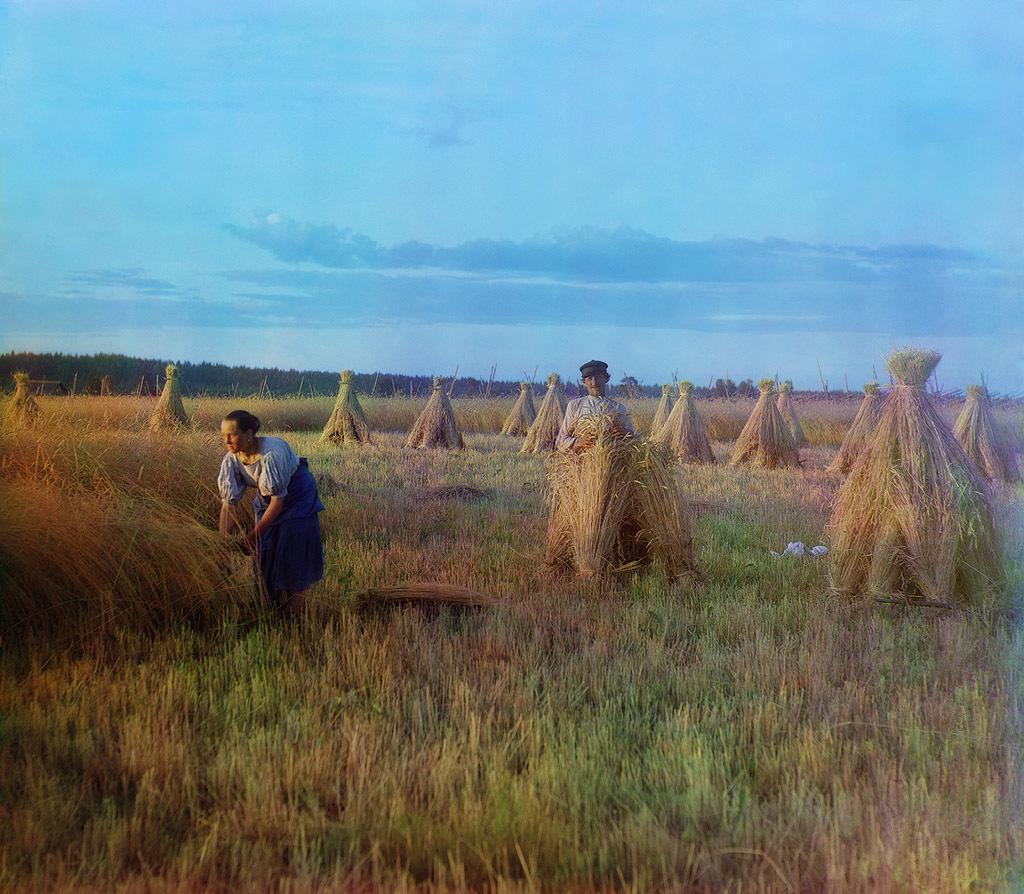Describe this image in one or two sentences. This is an animated image, in this image there is one man and one woman, at the bottom there are some crops and in the background there are trees. On the top of the image there is sky. 